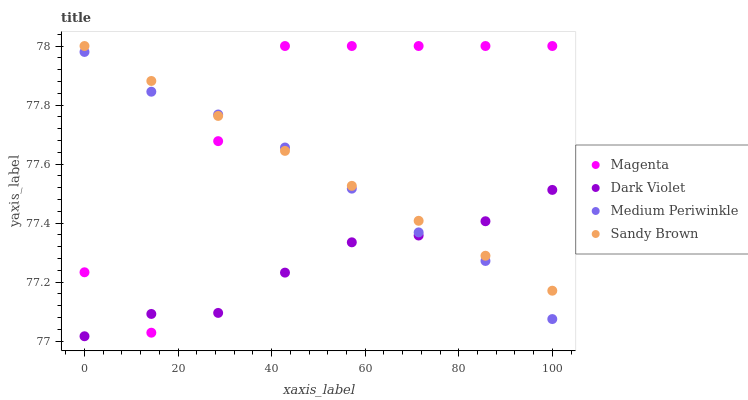Does Dark Violet have the minimum area under the curve?
Answer yes or no. Yes. Does Magenta have the maximum area under the curve?
Answer yes or no. Yes. Does Medium Periwinkle have the minimum area under the curve?
Answer yes or no. No. Does Medium Periwinkle have the maximum area under the curve?
Answer yes or no. No. Is Sandy Brown the smoothest?
Answer yes or no. Yes. Is Magenta the roughest?
Answer yes or no. Yes. Is Medium Periwinkle the smoothest?
Answer yes or no. No. Is Medium Periwinkle the roughest?
Answer yes or no. No. Does Dark Violet have the lowest value?
Answer yes or no. Yes. Does Magenta have the lowest value?
Answer yes or no. No. Does Magenta have the highest value?
Answer yes or no. Yes. Does Medium Periwinkle have the highest value?
Answer yes or no. No. Does Medium Periwinkle intersect Magenta?
Answer yes or no. Yes. Is Medium Periwinkle less than Magenta?
Answer yes or no. No. Is Medium Periwinkle greater than Magenta?
Answer yes or no. No. 